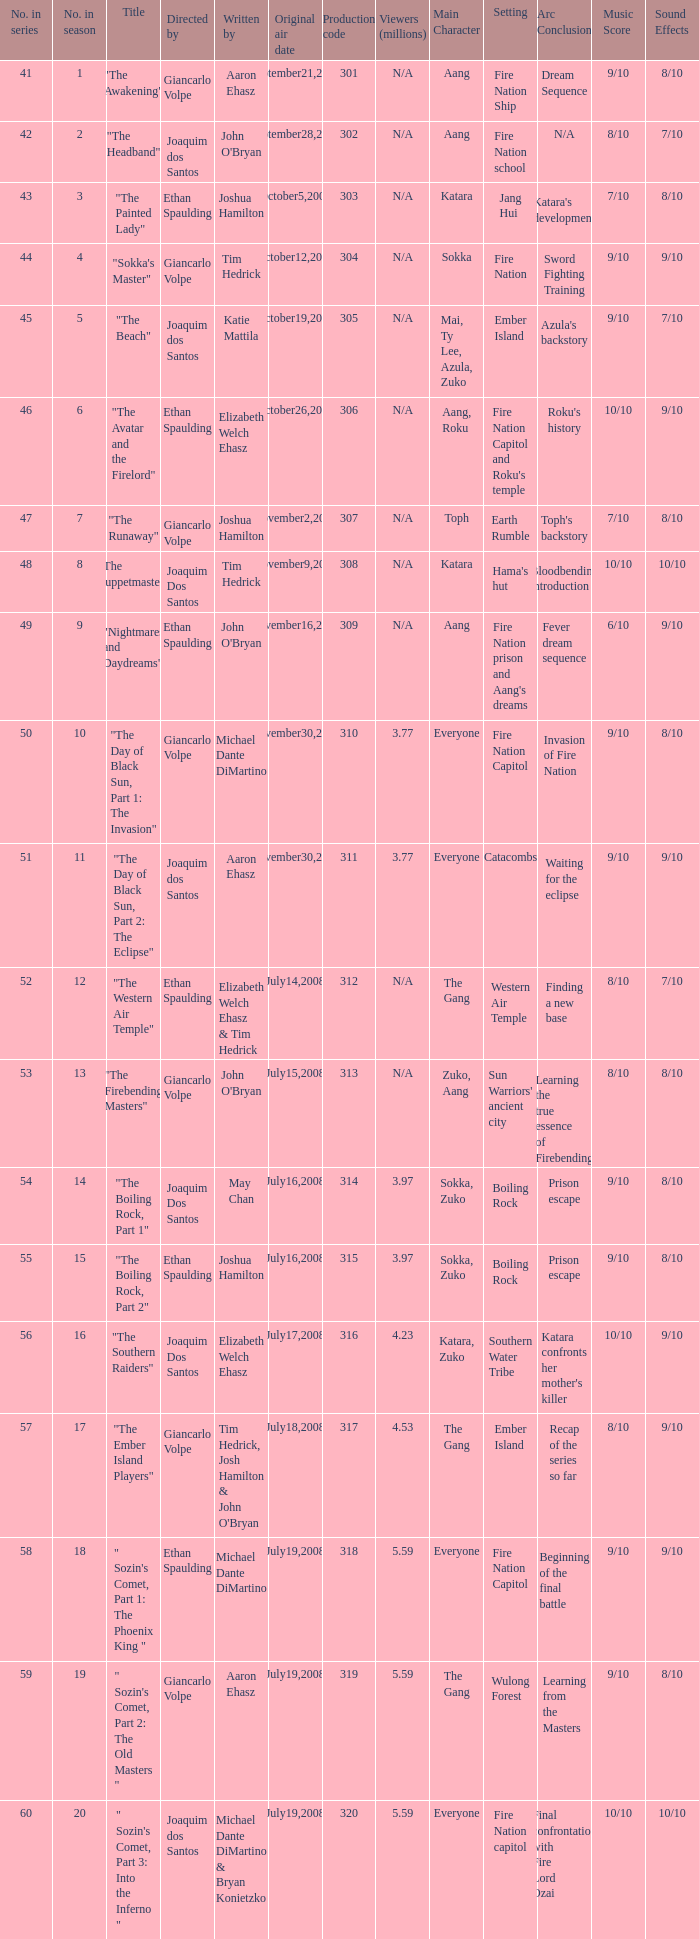How many viewers in millions for episode "sokka's master"? N/A. Parse the full table. {'header': ['No. in series', 'No. in season', 'Title', 'Directed by', 'Written by', 'Original air date', 'Production code', 'Viewers (millions)', 'Main Character', 'Setting', 'Arc Conclusion', 'Music Score', 'Sound Effects'], 'rows': [['41', '1', '"The Awakening"', 'Giancarlo Volpe', 'Aaron Ehasz', 'September21,2007', '301', 'N/A', 'Aang', 'Fire Nation Ship', 'Dream Sequence', '9/10', '8/10'], ['42', '2', '"The Headband"', 'Joaquim dos Santos', "John O'Bryan", 'September28,2007', '302', 'N/A', 'Aang', 'Fire Nation school', 'N/A', '8/10', '7/10'], ['43', '3', '"The Painted Lady"', 'Ethan Spaulding', 'Joshua Hamilton', 'October5,2007', '303', 'N/A', 'Katara', 'Jang Hui', "Katara's development", '7/10', '8/10'], ['44', '4', '"Sokka\'s Master"', 'Giancarlo Volpe', 'Tim Hedrick', 'October12,2007', '304', 'N/A', 'Sokka', 'Fire Nation', 'Sword Fighting Training', '9/10', '9/10'], ['45', '5', '"The Beach"', 'Joaquim dos Santos', 'Katie Mattila', 'October19,2007', '305', 'N/A', 'Mai, Ty Lee, Azula, Zuko', 'Ember Island', "Azula's backstory", '9/10', '7/10'], ['46', '6', '"The Avatar and the Firelord"', 'Ethan Spaulding', 'Elizabeth Welch Ehasz', 'October26,2007', '306', 'N/A', 'Aang, Roku', "Fire Nation Capitol and Roku's temple", "Roku's history", '10/10', '9/10'], ['47', '7', '"The Runaway"', 'Giancarlo Volpe', 'Joshua Hamilton', 'November2,2007', '307', 'N/A', 'Toph', 'Earth Rumble', "Toph's backstory", '7/10', '8/10'], ['48', '8', '"The Puppetmaster"', 'Joaquim Dos Santos', 'Tim Hedrick', 'November9,2007', '308', 'N/A', 'Katara', "Hama's hut", 'Bloodbending introduction', '10/10', '10/10'], ['49', '9', '"Nightmares and Daydreams"', 'Ethan Spaulding', "John O'Bryan", 'November16,2007', '309', 'N/A', 'Aang', "Fire Nation prison and Aang's dreams", 'Fever dream sequence', '6/10', '9/10'], ['50', '10', '"The Day of Black Sun, Part 1: The Invasion"', 'Giancarlo Volpe', 'Michael Dante DiMartino', 'November30,2007', '310', '3.77', 'Everyone', 'Fire Nation Capitol', 'Invasion of Fire Nation', '9/10', '8/10'], ['51', '11', '"The Day of Black Sun, Part 2: The Eclipse"', 'Joaquim dos Santos', 'Aaron Ehasz', 'November30,2007', '311', '3.77', 'Everyone', 'Catacombs', 'Waiting for the eclipse', '9/10', '9/10'], ['52', '12', '"The Western Air Temple"', 'Ethan Spaulding', 'Elizabeth Welch Ehasz & Tim Hedrick', 'July14,2008', '312', 'N/A', 'The Gang', 'Western Air Temple', 'Finding a new base', '8/10', '7/10'], ['53', '13', '"The Firebending Masters"', 'Giancarlo Volpe', "John O'Bryan", 'July15,2008', '313', 'N/A', 'Zuko, Aang', "Sun Warriors' ancient city", 'Learning the true essence of Firebending', '8/10', '8/10'], ['54', '14', '"The Boiling Rock, Part 1"', 'Joaquim Dos Santos', 'May Chan', 'July16,2008', '314', '3.97', 'Sokka, Zuko', 'Boiling Rock', 'Prison escape', '9/10', '8/10'], ['55', '15', '"The Boiling Rock, Part 2"', 'Ethan Spaulding', 'Joshua Hamilton', 'July16,2008', '315', '3.97', 'Sokka, Zuko', 'Boiling Rock', 'Prison escape', '9/10', '8/10'], ['56', '16', '"The Southern Raiders"', 'Joaquim Dos Santos', 'Elizabeth Welch Ehasz', 'July17,2008', '316', '4.23', 'Katara, Zuko', 'Southern Water Tribe', "Katara confronts her mother's killer", '10/10', '9/10'], ['57', '17', '"The Ember Island Players"', 'Giancarlo Volpe', "Tim Hedrick, Josh Hamilton & John O'Bryan", 'July18,2008', '317', '4.53', 'The Gang', 'Ember Island', 'Recap of the series so far', '8/10', '9/10'], ['58', '18', '" Sozin\'s Comet, Part 1: The Phoenix King "', 'Ethan Spaulding', 'Michael Dante DiMartino', 'July19,2008', '318', '5.59', 'Everyone', 'Fire Nation Capitol', 'Beginning of the final battle', '9/10', '9/10'], ['59', '19', '" Sozin\'s Comet, Part 2: The Old Masters "', 'Giancarlo Volpe', 'Aaron Ehasz', 'July19,2008', '319', '5.59', 'The Gang', 'Wulong Forest', 'Learning from the Masters', '9/10', '8/10'], ['60', '20', '" Sozin\'s Comet, Part 3: Into the Inferno "', 'Joaquim dos Santos', 'Michael Dante DiMartino & Bryan Konietzko', 'July19,2008', '320', '5.59', 'Everyone', 'Fire Nation capitol', 'Final confrontation with Fire Lord Ozai', '10/10', '10/10']]} 